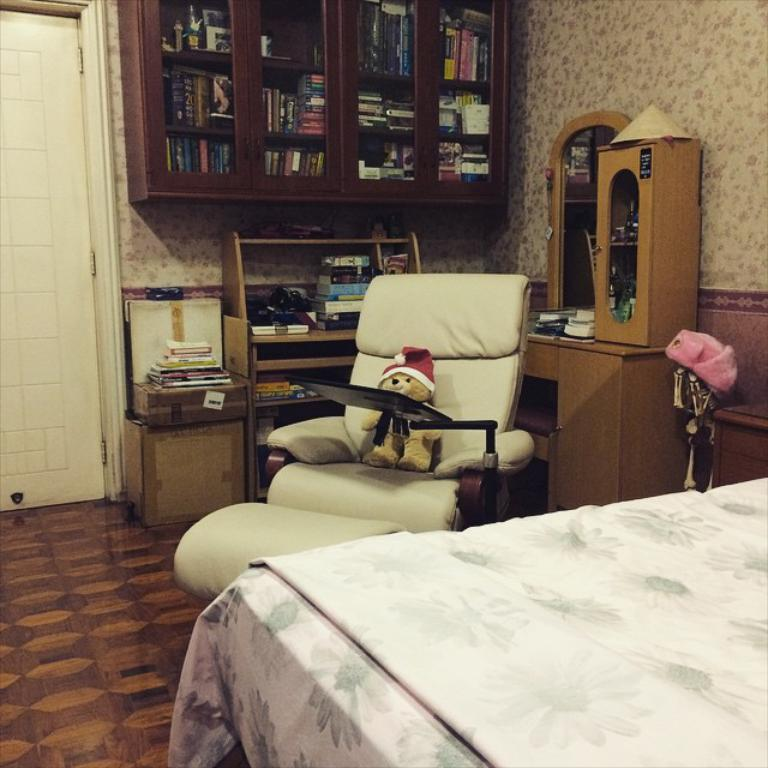What piece of furniture is present in the image? There is a bed in the image. What object is on the chair in the image? There is a soft toy on a chair in the image. What can be seen in the background of the image? There are books visible in the background of the image, presumably in a cupboard. Is there a tray with food on it in the image? No, there is no tray with food present in the image. 